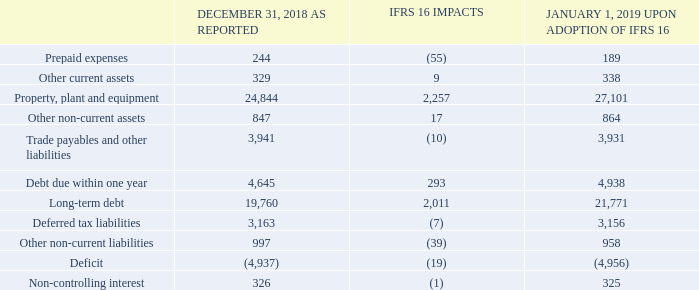Note 35 Adoption of IFRS 16
Upon adoption of IFRS 16 on January 1, 2019, we recognized right-of-use assets of $2,257 million within property, plant and equipment, and lease liabilities of $2,304 million within debt, with an increase to our deficit of $19 million. These amounts were recognized in addition to assets under finance leases of $1,947 million and the corresponding finance lease liabilities of $2,097 million at December 31, 2018 under IAS 17. As a result, on January 1, 2019, our total right-of-use assets and lease liabilities amounted to $4,204 million and $4,401 million, respectively. The table below shows the impacts of adopting IFRS  16 on our January 1, 2019 consolidated statement of financial position.
BCE’s operating lease commitments at December 31, 2018 were $1,612 million. The difference between operating lease commitments at December 31, 2018 and lease liabilities of $2,304 million upon adoption of IFRS 16 at January 1, 2019, is due mainly to an increase of $1,122 million related to renewal options reasonably certain to be exercised, an increase of $112 million mainly related to non-monetary transactions and a decrease of ($542) million as a result of discounting applied to future lease payments, which was determined using a weighted average incremental borrowing rate of 3.49% at January 1, 2019.
How much right-of-use assets was recognized upon adoption of IFRS 16 on January 1, 2019? $2,257 million within property, plant and equipment. What is the weighted average incremental borrowing rate used in 2019? 3.49%. What was recognized upon adoption of IFRS 16 in 2019? Right-of-use assets, lease liabilities. How many components had a positive value of IFRS 16 Impacts? Other current assets##Property, plant and equipment##Other non-current assets##Debt due within one year##Long-term debt
Answer: 5. What is the difference between the right-of-use assets recognized within property, plant and equipment and the lease liabilities recognized within debt upon adoption of IFRS 16?
Answer scale should be: million. $2,304 million - $2,257 million 
Answer: 47. What is the percentage change in property, plant and equipment upon adoption of IFRS 16?
Answer scale should be: percent. (27,101-24,844)/24,844
Answer: 9.08. 